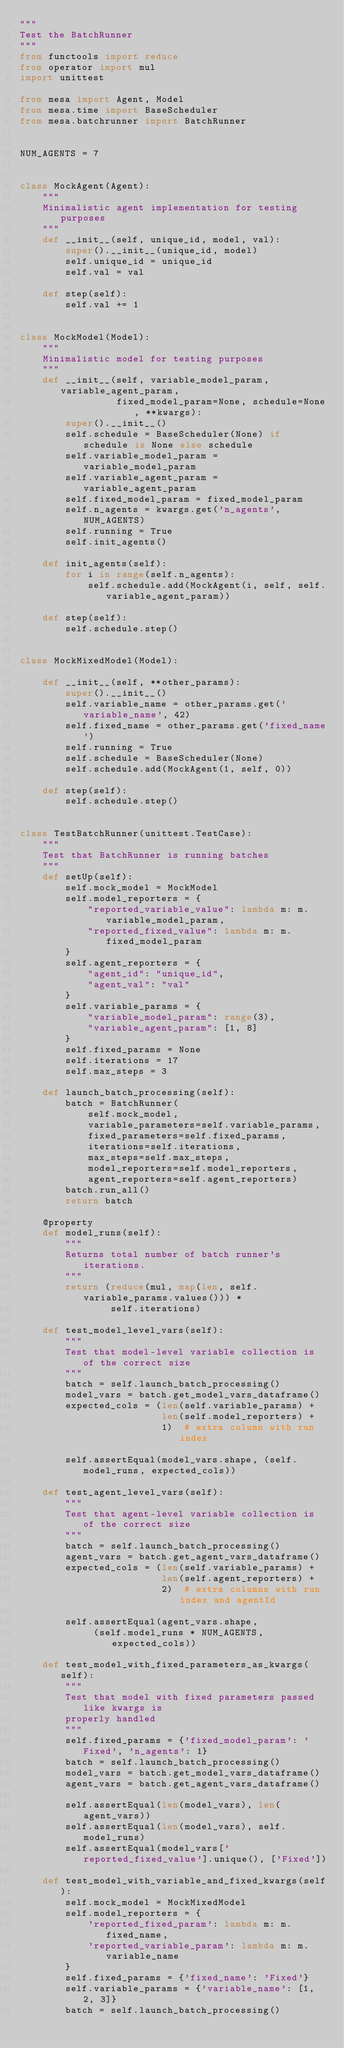Convert code to text. <code><loc_0><loc_0><loc_500><loc_500><_Python_>"""
Test the BatchRunner
"""
from functools import reduce
from operator import mul
import unittest

from mesa import Agent, Model
from mesa.time import BaseScheduler
from mesa.batchrunner import BatchRunner


NUM_AGENTS = 7


class MockAgent(Agent):
    """
    Minimalistic agent implementation for testing purposes
    """
    def __init__(self, unique_id, model, val):
        super().__init__(unique_id, model)
        self.unique_id = unique_id
        self.val = val

    def step(self):
        self.val += 1


class MockModel(Model):
    """
    Minimalistic model for testing purposes
    """
    def __init__(self, variable_model_param, variable_agent_param,
                 fixed_model_param=None, schedule=None, **kwargs):
        super().__init__()
        self.schedule = BaseScheduler(None) if schedule is None else schedule
        self.variable_model_param = variable_model_param
        self.variable_agent_param = variable_agent_param
        self.fixed_model_param = fixed_model_param
        self.n_agents = kwargs.get('n_agents', NUM_AGENTS)
        self.running = True
        self.init_agents()

    def init_agents(self):
        for i in range(self.n_agents):
            self.schedule.add(MockAgent(i, self, self.variable_agent_param))

    def step(self):
        self.schedule.step()


class MockMixedModel(Model):

    def __init__(self, **other_params):
        super().__init__()
        self.variable_name = other_params.get('variable_name', 42)
        self.fixed_name = other_params.get('fixed_name')
        self.running = True
        self.schedule = BaseScheduler(None)
        self.schedule.add(MockAgent(1, self, 0))

    def step(self):
        self.schedule.step()


class TestBatchRunner(unittest.TestCase):
    """
    Test that BatchRunner is running batches
    """
    def setUp(self):
        self.mock_model = MockModel
        self.model_reporters = {
            "reported_variable_value": lambda m: m.variable_model_param,
            "reported_fixed_value": lambda m: m.fixed_model_param
        }
        self.agent_reporters = {
            "agent_id": "unique_id",
            "agent_val": "val"
        }
        self.variable_params = {
            "variable_model_param": range(3),
            "variable_agent_param": [1, 8]
        }
        self.fixed_params = None
        self.iterations = 17
        self.max_steps = 3

    def launch_batch_processing(self):
        batch = BatchRunner(
            self.mock_model,
            variable_parameters=self.variable_params,
            fixed_parameters=self.fixed_params,
            iterations=self.iterations,
            max_steps=self.max_steps,
            model_reporters=self.model_reporters,
            agent_reporters=self.agent_reporters)
        batch.run_all()
        return batch

    @property
    def model_runs(self):
        """
        Returns total number of batch runner's iterations.
        """
        return (reduce(mul, map(len, self.variable_params.values())) *
                self.iterations)

    def test_model_level_vars(self):
        """
        Test that model-level variable collection is of the correct size
        """
        batch = self.launch_batch_processing()
        model_vars = batch.get_model_vars_dataframe()
        expected_cols = (len(self.variable_params) +
                         len(self.model_reporters) +
                         1)  # extra column with run index

        self.assertEqual(model_vars.shape, (self.model_runs, expected_cols))

    def test_agent_level_vars(self):
        """
        Test that agent-level variable collection is of the correct size
        """
        batch = self.launch_batch_processing()
        agent_vars = batch.get_agent_vars_dataframe()
        expected_cols = (len(self.variable_params) +
                         len(self.agent_reporters) +
                         2)  # extra columns with run index and agentId

        self.assertEqual(agent_vars.shape,
             (self.model_runs * NUM_AGENTS, expected_cols))

    def test_model_with_fixed_parameters_as_kwargs(self):
        """
        Test that model with fixed parameters passed like kwargs is
        properly handled
        """
        self.fixed_params = {'fixed_model_param': 'Fixed', 'n_agents': 1}
        batch = self.launch_batch_processing()
        model_vars = batch.get_model_vars_dataframe()
        agent_vars = batch.get_agent_vars_dataframe()

        self.assertEqual(len(model_vars), len(agent_vars))
        self.assertEqual(len(model_vars), self.model_runs)
        self.assertEqual(model_vars['reported_fixed_value'].unique(), ['Fixed'])

    def test_model_with_variable_and_fixed_kwargs(self):
        self.mock_model = MockMixedModel
        self.model_reporters = {
            'reported_fixed_param': lambda m: m.fixed_name,
            'reported_variable_param': lambda m: m.variable_name
        }
        self.fixed_params = {'fixed_name': 'Fixed'}
        self.variable_params = {'variable_name': [1, 2, 3]}
        batch = self.launch_batch_processing()</code> 